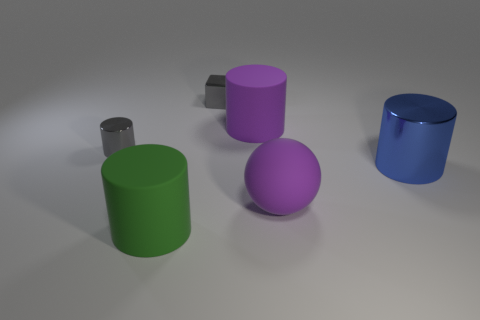There is a ball; is its color the same as the rubber cylinder on the right side of the tiny gray metallic block?
Give a very brief answer. Yes. The metallic cylinder in front of the cylinder that is left of the large green rubber cylinder is what color?
Give a very brief answer. Blue. What number of blue objects are there?
Keep it short and to the point. 1. How many rubber objects are either cyan cylinders or tiny things?
Provide a succinct answer. 0. How many cylinders are the same color as the large matte ball?
Give a very brief answer. 1. What is the material of the purple object that is in front of the large purple matte thing on the left side of the big sphere?
Offer a terse response. Rubber. What size is the blue thing?
Your answer should be compact. Large. How many metallic blocks have the same size as the blue metallic object?
Ensure brevity in your answer.  0. What number of big yellow matte things are the same shape as the green object?
Provide a succinct answer. 0. Is the number of big purple rubber balls that are behind the small cube the same as the number of small yellow shiny cylinders?
Your answer should be compact. Yes. 